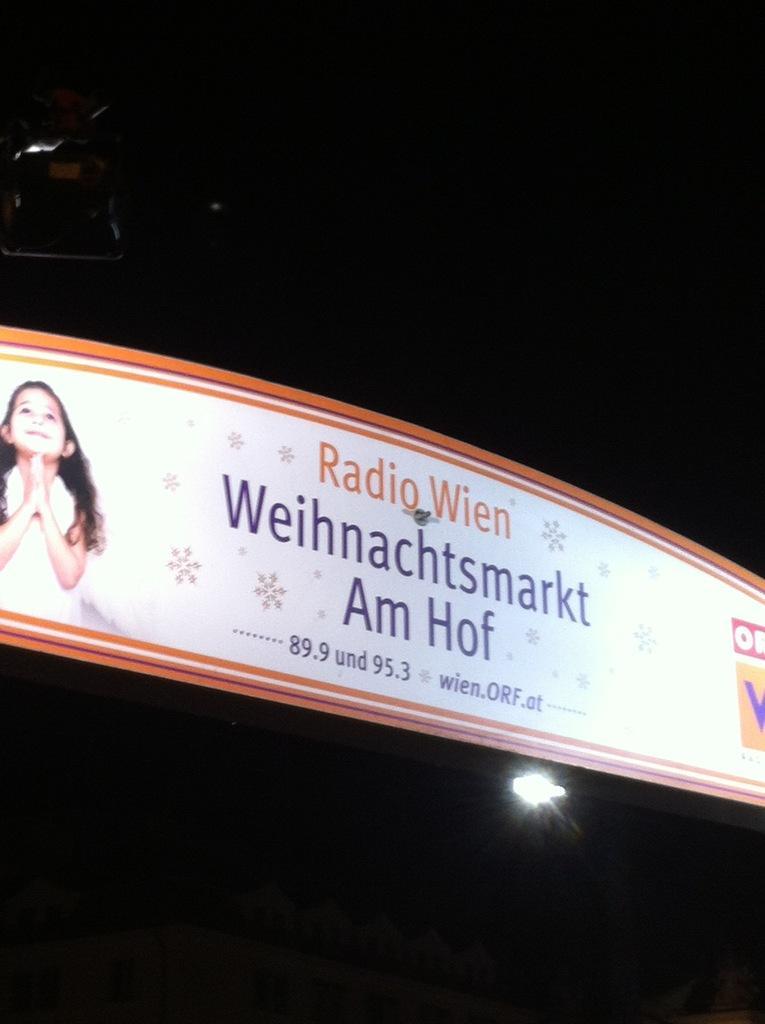Could you give a brief overview of what you see in this image? In this picture it looks like an advertisement of something. 